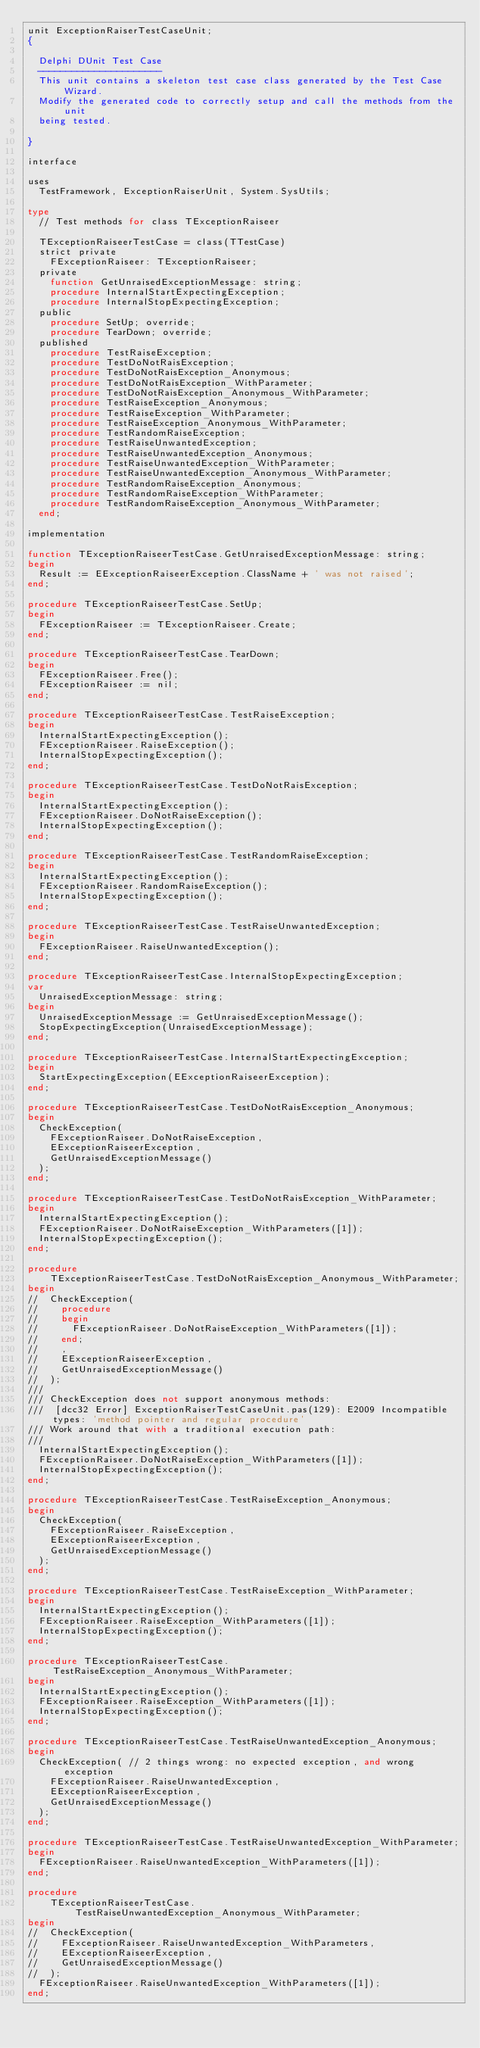Convert code to text. <code><loc_0><loc_0><loc_500><loc_500><_Pascal_>unit ExceptionRaiserTestCaseUnit;
{

  Delphi DUnit Test Case
  ----------------------
  This unit contains a skeleton test case class generated by the Test Case Wizard.
  Modify the generated code to correctly setup and call the methods from the unit
  being tested.

}

interface

uses
  TestFramework, ExceptionRaiserUnit, System.SysUtils;

type
  // Test methods for class TExceptionRaiseer

  TExceptionRaiseerTestCase = class(TTestCase)
  strict private
    FExceptionRaiseer: TExceptionRaiseer;
  private
    function GetUnraisedExceptionMessage: string;
    procedure InternalStartExpectingException;
    procedure InternalStopExpectingException;
  public
    procedure SetUp; override;
    procedure TearDown; override;
  published
    procedure TestRaiseException;
    procedure TestDoNotRaisException;
    procedure TestDoNotRaisException_Anonymous;
    procedure TestDoNotRaisException_WithParameter;
    procedure TestDoNotRaisException_Anonymous_WithParameter;
    procedure TestRaiseException_Anonymous;
    procedure TestRaiseException_WithParameter;
    procedure TestRaiseException_Anonymous_WithParameter;
    procedure TestRandomRaiseException;
    procedure TestRaiseUnwantedException;
    procedure TestRaiseUnwantedException_Anonymous;
    procedure TestRaiseUnwantedException_WithParameter;
    procedure TestRaiseUnwantedException_Anonymous_WithParameter;
    procedure TestRandomRaiseException_Anonymous;
    procedure TestRandomRaiseException_WithParameter;
    procedure TestRandomRaiseException_Anonymous_WithParameter;
  end;

implementation

function TExceptionRaiseerTestCase.GetUnraisedExceptionMessage: string;
begin
  Result := EExceptionRaiseerException.ClassName + ' was not raised';
end;

procedure TExceptionRaiseerTestCase.SetUp;
begin
  FExceptionRaiseer := TExceptionRaiseer.Create;
end;

procedure TExceptionRaiseerTestCase.TearDown;
begin
  FExceptionRaiseer.Free();
  FExceptionRaiseer := nil;
end;

procedure TExceptionRaiseerTestCase.TestRaiseException;
begin
  InternalStartExpectingException();
  FExceptionRaiseer.RaiseException();
  InternalStopExpectingException();
end;

procedure TExceptionRaiseerTestCase.TestDoNotRaisException;
begin
  InternalStartExpectingException();
  FExceptionRaiseer.DoNotRaiseException();
  InternalStopExpectingException();
end;

procedure TExceptionRaiseerTestCase.TestRandomRaiseException;
begin
  InternalStartExpectingException();
  FExceptionRaiseer.RandomRaiseException();
  InternalStopExpectingException();
end;

procedure TExceptionRaiseerTestCase.TestRaiseUnwantedException;
begin
  FExceptionRaiseer.RaiseUnwantedException();
end;

procedure TExceptionRaiseerTestCase.InternalStopExpectingException;
var
  UnraisedExceptionMessage: string;
begin
  UnraisedExceptionMessage := GetUnraisedExceptionMessage();
  StopExpectingException(UnraisedExceptionMessage);
end;

procedure TExceptionRaiseerTestCase.InternalStartExpectingException;
begin
  StartExpectingException(EExceptionRaiseerException);
end;

procedure TExceptionRaiseerTestCase.TestDoNotRaisException_Anonymous;
begin
  CheckException(
    FExceptionRaiseer.DoNotRaiseException,
    EExceptionRaiseerException,
    GetUnraisedExceptionMessage()
  );
end;

procedure TExceptionRaiseerTestCase.TestDoNotRaisException_WithParameter;
begin
  InternalStartExpectingException();
  FExceptionRaiseer.DoNotRaiseException_WithParameters([1]);
  InternalStopExpectingException();
end;

procedure
    TExceptionRaiseerTestCase.TestDoNotRaisException_Anonymous_WithParameter;
begin
//  CheckException(
//    procedure
//    begin
//      FExceptionRaiseer.DoNotRaiseException_WithParameters([1]);
//    end;
//    ,
//    EExceptionRaiseerException,
//    GetUnraisedExceptionMessage()
//  );
///
/// CheckException does not support anonymous methods:
///  [dcc32 Error] ExceptionRaiserTestCaseUnit.pas(129): E2009 Incompatible types: 'method pointer and regular procedure'
/// Work around that with a traditional execution path:
///
  InternalStartExpectingException();
  FExceptionRaiseer.DoNotRaiseException_WithParameters([1]);
  InternalStopExpectingException();
end;

procedure TExceptionRaiseerTestCase.TestRaiseException_Anonymous;
begin
  CheckException(
    FExceptionRaiseer.RaiseException,
    EExceptionRaiseerException,
    GetUnraisedExceptionMessage()
  );
end;

procedure TExceptionRaiseerTestCase.TestRaiseException_WithParameter;
begin
  InternalStartExpectingException();
  FExceptionRaiseer.RaiseException_WithParameters([1]);
  InternalStopExpectingException();
end;

procedure TExceptionRaiseerTestCase.TestRaiseException_Anonymous_WithParameter;
begin
  InternalStartExpectingException();
  FExceptionRaiseer.RaiseException_WithParameters([1]);
  InternalStopExpectingException();
end;

procedure TExceptionRaiseerTestCase.TestRaiseUnwantedException_Anonymous;
begin
  CheckException( // 2 things wrong: no expected exception, and wrong exception
    FExceptionRaiseer.RaiseUnwantedException,
    EExceptionRaiseerException,
    GetUnraisedExceptionMessage()
  );
end;

procedure TExceptionRaiseerTestCase.TestRaiseUnwantedException_WithParameter;
begin
  FExceptionRaiseer.RaiseUnwantedException_WithParameters([1]);
end;

procedure
    TExceptionRaiseerTestCase.TestRaiseUnwantedException_Anonymous_WithParameter;
begin
//  CheckException(
//    FExceptionRaiseer.RaiseUnwantedException_WithParameters,
//    EExceptionRaiseerException,
//    GetUnraisedExceptionMessage()
//  );
  FExceptionRaiseer.RaiseUnwantedException_WithParameters([1]);
end;
</code> 